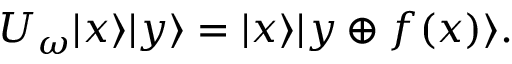<formula> <loc_0><loc_0><loc_500><loc_500>U _ { \omega } | x \rangle | y \rangle = | x \rangle | y \oplus f ( x ) \rangle .</formula> 